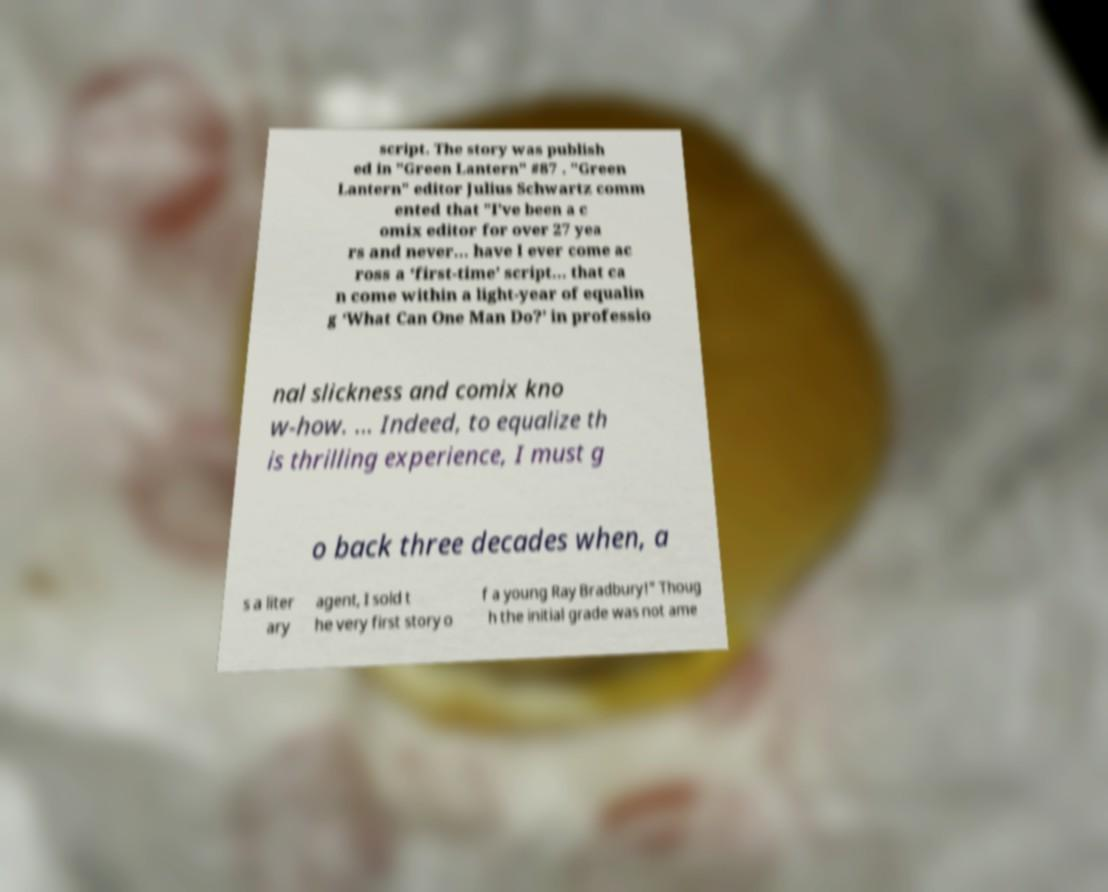For documentation purposes, I need the text within this image transcribed. Could you provide that? script. The story was publish ed in "Green Lantern" #87 . "Green Lantern" editor Julius Schwartz comm ented that "I’ve been a c omix editor for over 27 yea rs and never... have I ever come ac ross a ‘first-time’ script... that ca n come within a light-year of equalin g ‘What Can One Man Do?’ in professio nal slickness and comix kno w-how. ... Indeed, to equalize th is thrilling experience, I must g o back three decades when, a s a liter ary agent, I sold t he very first story o f a young Ray Bradbury!" Thoug h the initial grade was not ame 